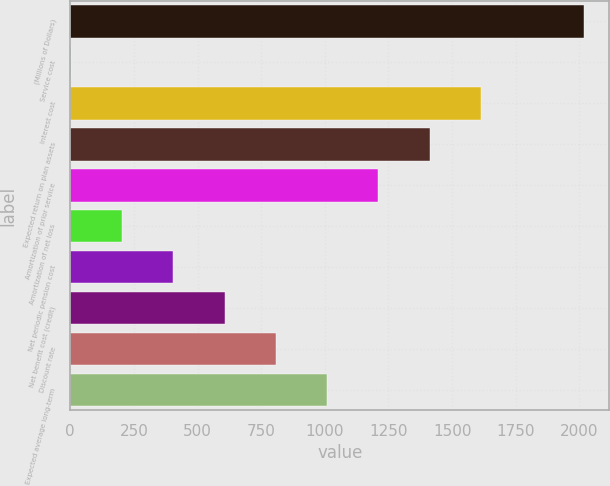<chart> <loc_0><loc_0><loc_500><loc_500><bar_chart><fcel>(Millions of Dollars)<fcel>Service cost<fcel>Interest cost<fcel>Expected return on plan assets<fcel>Amortization of prior service<fcel>Amortization of net loss<fcel>Net periodic pension cost<fcel>Net benefit cost (credit)<fcel>Discount rate<fcel>Expected average long-term<nl><fcel>2016<fcel>2<fcel>1613.2<fcel>1411.8<fcel>1210.4<fcel>203.4<fcel>404.8<fcel>606.2<fcel>807.6<fcel>1009<nl></chart> 